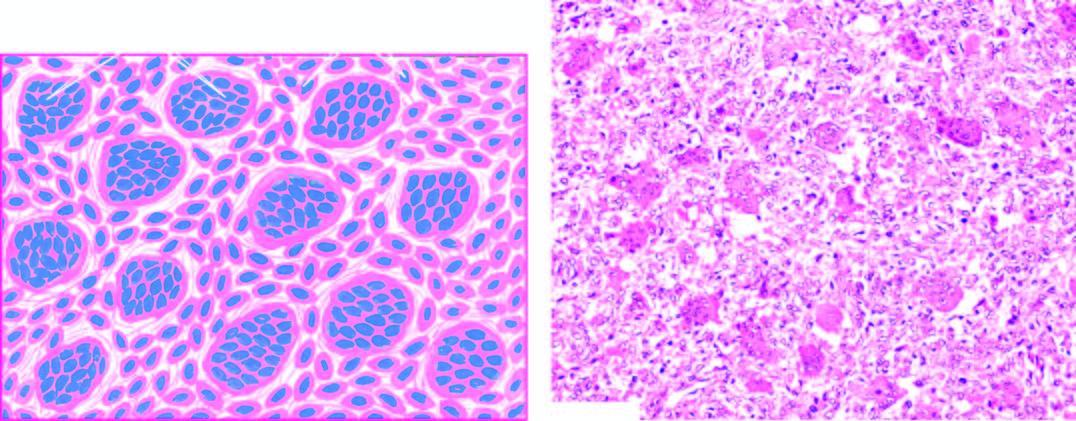does microscopy reveal osteoclast-like multinucleate giant cells which are regularly distributed among the mononuclear stromal cells?
Answer the question using a single word or phrase. Yes 